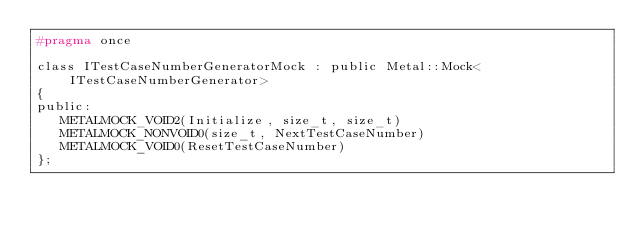<code> <loc_0><loc_0><loc_500><loc_500><_C_>#pragma once

class ITestCaseNumberGeneratorMock : public Metal::Mock<ITestCaseNumberGenerator>
{
public:
   METALMOCK_VOID2(Initialize, size_t, size_t)
   METALMOCK_NONVOID0(size_t, NextTestCaseNumber)
   METALMOCK_VOID0(ResetTestCaseNumber)
};
</code> 